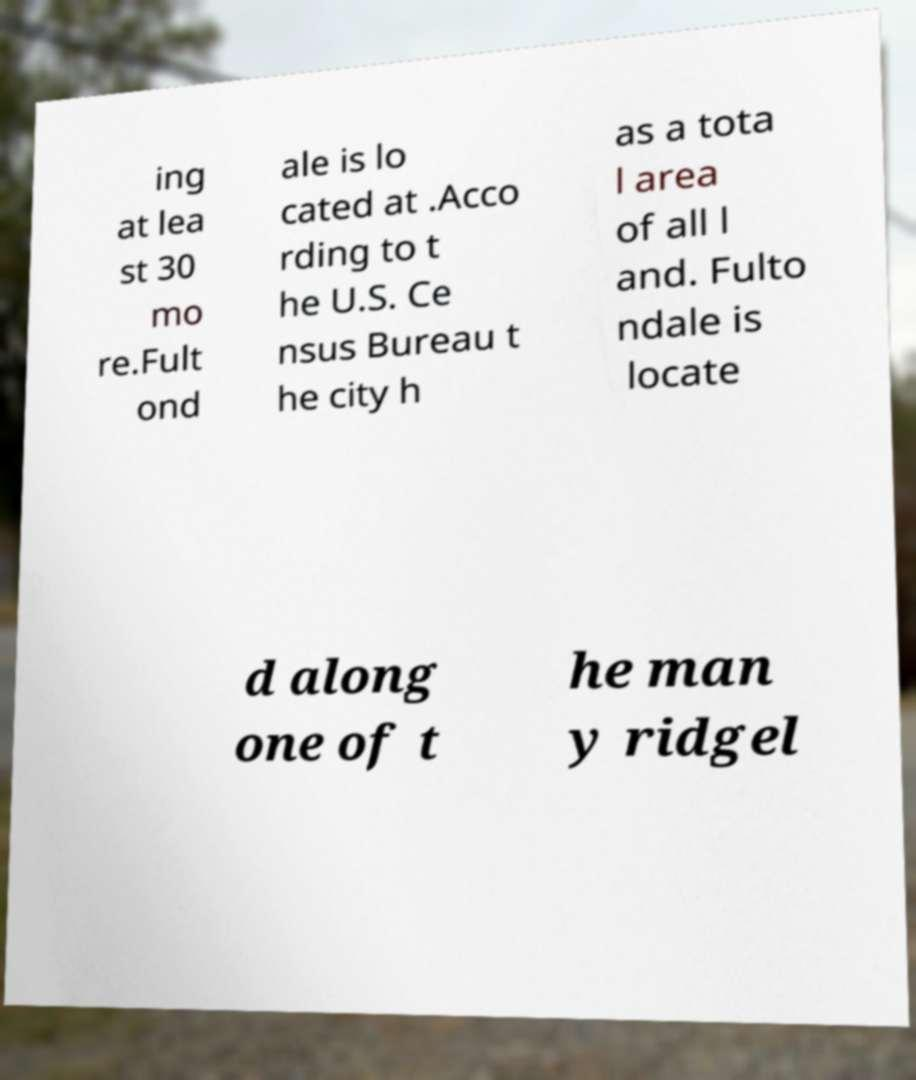Please read and relay the text visible in this image. What does it say? ing at lea st 30 mo re.Fult ond ale is lo cated at .Acco rding to t he U.S. Ce nsus Bureau t he city h as a tota l area of all l and. Fulto ndale is locate d along one of t he man y ridgel 